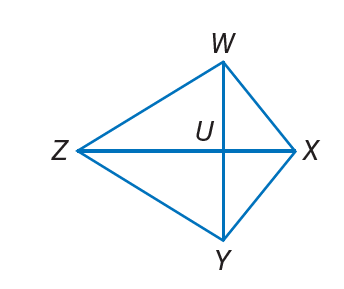Question: W X Y Z is a kite. If m \angle W X Y = 120, m \angle W Z Y = 4 x, and m \angle Z W X = 10 x, find m \angle Z Y X.
Choices:
A. 24
B. 40
C. 60
D. 100
Answer with the letter. Answer: D Question: W X Y Z is a kite. If m \angle W X Y = 13 x + 24, m \angle W Z Y = 35, and m \angle Z W X = 13 x + 14, find m \angle Z Y X.
Choices:
A. 13
B. 24
C. 105
D. 210
Answer with the letter. Answer: C 